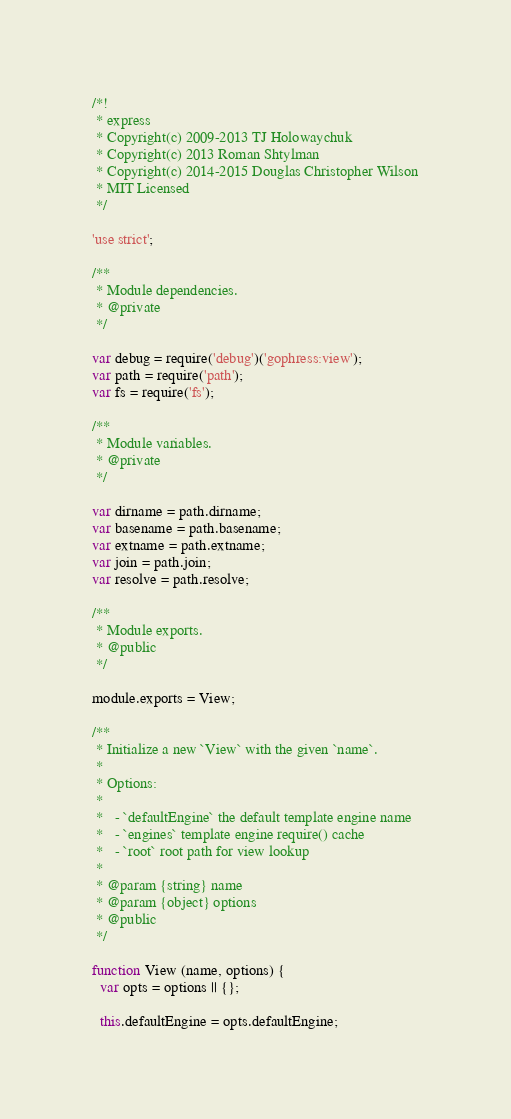<code> <loc_0><loc_0><loc_500><loc_500><_JavaScript_>/*!
 * express
 * Copyright(c) 2009-2013 TJ Holowaychuk
 * Copyright(c) 2013 Roman Shtylman
 * Copyright(c) 2014-2015 Douglas Christopher Wilson
 * MIT Licensed
 */

'use strict';

/**
 * Module dependencies.
 * @private
 */

var debug = require('debug')('gophress:view');
var path = require('path');
var fs = require('fs');

/**
 * Module variables.
 * @private
 */

var dirname = path.dirname;
var basename = path.basename;
var extname = path.extname;
var join = path.join;
var resolve = path.resolve;

/**
 * Module exports.
 * @public
 */

module.exports = View;

/**
 * Initialize a new `View` with the given `name`.
 *
 * Options:
 *
 *   - `defaultEngine` the default template engine name
 *   - `engines` template engine require() cache
 *   - `root` root path for view lookup
 *
 * @param {string} name
 * @param {object} options
 * @public
 */

function View (name, options) {
  var opts = options || {};

  this.defaultEngine = opts.defaultEngine;</code> 